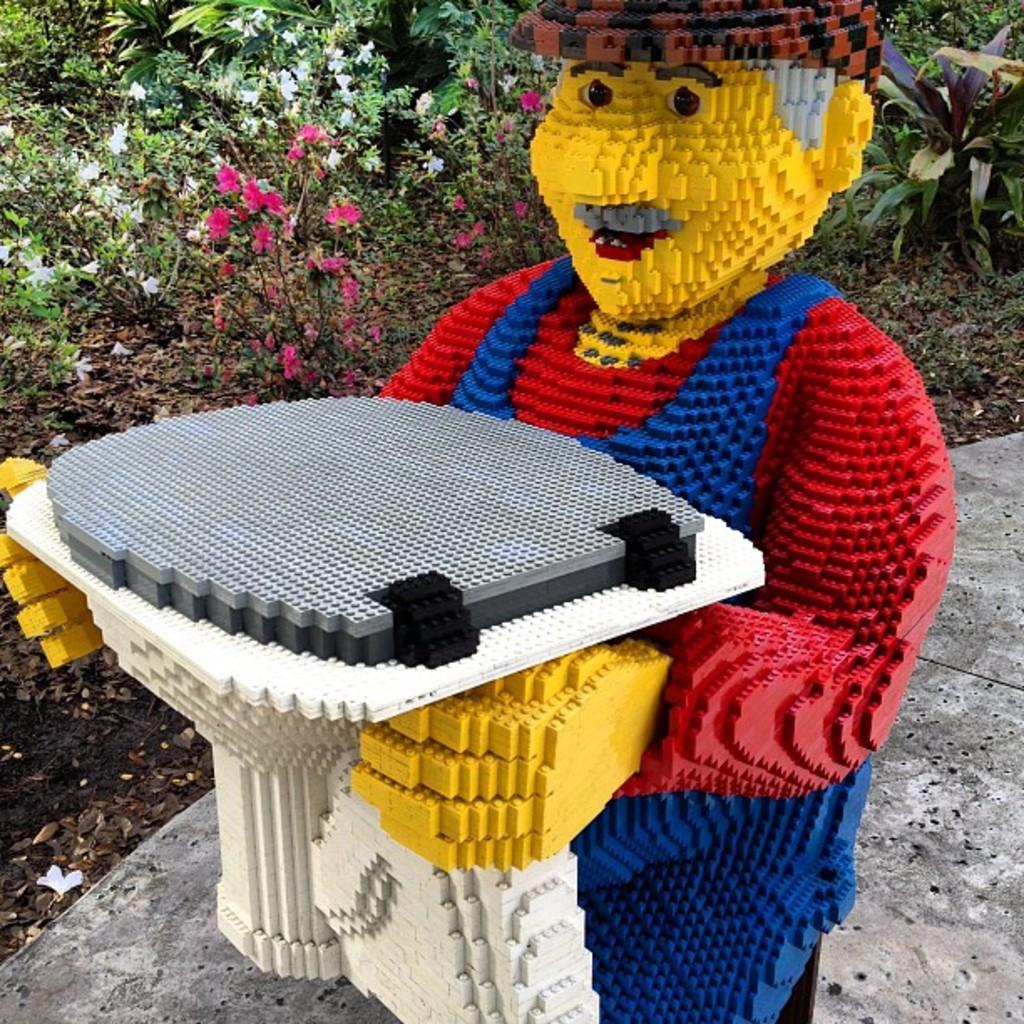What is the main subject in the image? There is a statue in the image. What can be seen in the background of the image? There are plants and flowers in the background of the image. How does the statue contribute to the growth of the flowers in the image? The statue does not contribute to the growth of the flowers in the image; it is a separate object. 